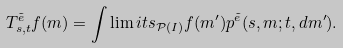<formula> <loc_0><loc_0><loc_500><loc_500>T _ { s , t } ^ { \tilde { e } } f ( m ) = \int \lim i t s _ { \mathcal { P } ( I ) } f ( m ^ { \prime } ) p ^ { \tilde { e } } ( s , m ; t , d m ^ { \prime } ) .</formula> 